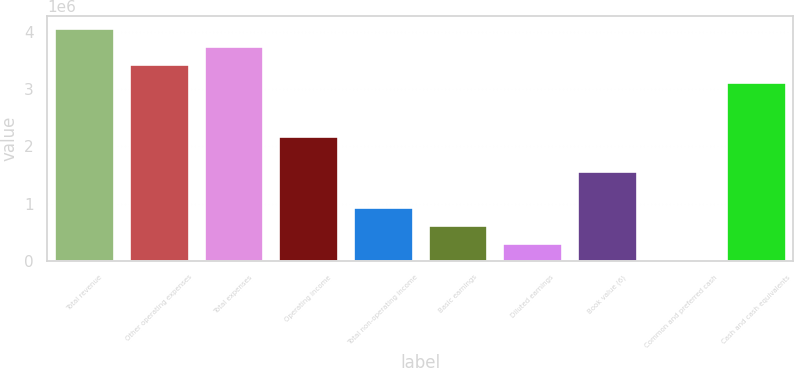Convert chart to OTSL. <chart><loc_0><loc_0><loc_500><loc_500><bar_chart><fcel>Total revenue<fcel>Other operating expenses<fcel>Total expenses<fcel>Operating income<fcel>Total non-operating income<fcel>Basic earnings<fcel>Diluted earnings<fcel>Book value (6)<fcel>Common and preferred cash<fcel>Cash and cash equivalents<nl><fcel>4.07045e+06<fcel>3.44423e+06<fcel>3.75734e+06<fcel>2.19178e+06<fcel>939338<fcel>626226<fcel>313115<fcel>1.56556e+06<fcel>4<fcel>3.13112e+06<nl></chart> 